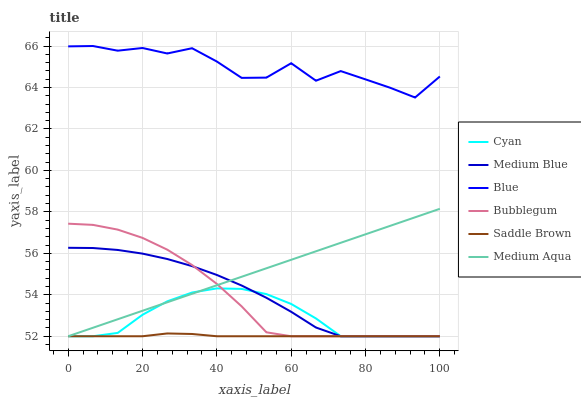Does Saddle Brown have the minimum area under the curve?
Answer yes or no. Yes. Does Blue have the maximum area under the curve?
Answer yes or no. Yes. Does Medium Blue have the minimum area under the curve?
Answer yes or no. No. Does Medium Blue have the maximum area under the curve?
Answer yes or no. No. Is Medium Aqua the smoothest?
Answer yes or no. Yes. Is Blue the roughest?
Answer yes or no. Yes. Is Medium Blue the smoothest?
Answer yes or no. No. Is Medium Blue the roughest?
Answer yes or no. No. Does Medium Blue have the lowest value?
Answer yes or no. Yes. Does Blue have the highest value?
Answer yes or no. Yes. Does Medium Blue have the highest value?
Answer yes or no. No. Is Medium Aqua less than Blue?
Answer yes or no. Yes. Is Blue greater than Saddle Brown?
Answer yes or no. Yes. Does Cyan intersect Medium Blue?
Answer yes or no. Yes. Is Cyan less than Medium Blue?
Answer yes or no. No. Is Cyan greater than Medium Blue?
Answer yes or no. No. Does Medium Aqua intersect Blue?
Answer yes or no. No. 